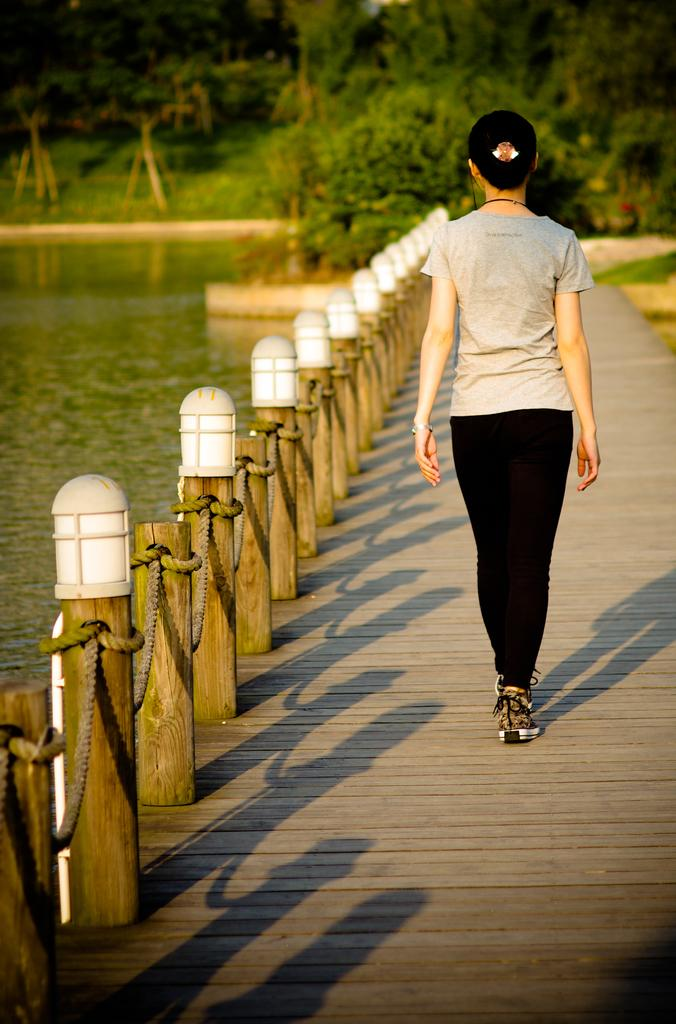Who is the main subject in the foreground of the image? There is a woman in the foreground of the image. What is the woman doing in the image? The woman is walking on a bridge. What can be seen in the background of the image? There is railing, water, and trees visible in the background of the image. How many kittens are playing on the drum in the background of the image? There are no kittens or drums present in the image. What type of patch is visible on the woman's clothing in the image? There is no patch visible on the woman's clothing in the image. 